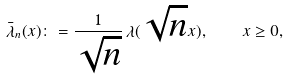Convert formula to latex. <formula><loc_0><loc_0><loc_500><loc_500>\bar { \lambda } _ { n } ( x ) \colon = \frac { 1 } { \sqrt { n } } \, \lambda ( \sqrt { n } x ) , \quad x \geq 0 ,</formula> 